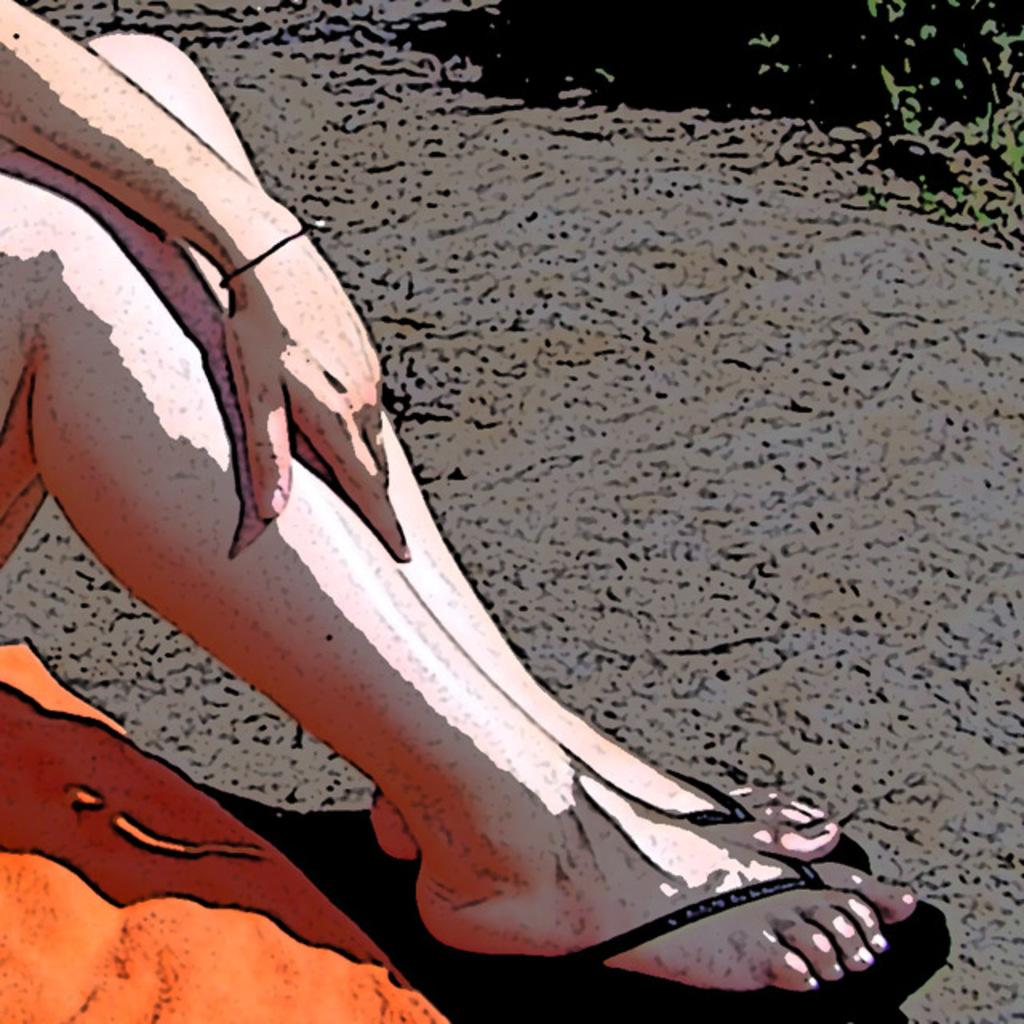What type of image is depicted in the picture? There is a cartoon in the image. What part of a person can be seen in the image? Human legs are visible in the image. Where is the hat located in the image? The hat is located on the left side of the image. What type of summer activity is taking place in the image? There is no indication of a summer activity in the image, as it features a cartoon with human legs and a hat. How many cents are visible in the image? There are no cents present in the image. 